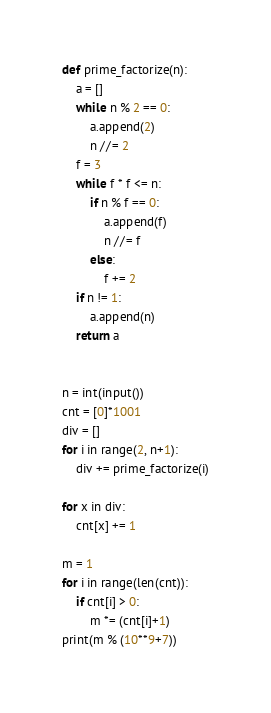<code> <loc_0><loc_0><loc_500><loc_500><_Python_>def prime_factorize(n):
    a = []
    while n % 2 == 0:
        a.append(2)
        n //= 2
    f = 3
    while f * f <= n:
        if n % f == 0:
            a.append(f)
            n //= f
        else:
            f += 2
    if n != 1:
        a.append(n)
    return a


n = int(input())
cnt = [0]*1001
div = []
for i in range(2, n+1):
    div += prime_factorize(i)

for x in div:
    cnt[x] += 1

m = 1
for i in range(len(cnt)):
    if cnt[i] > 0:
        m *= (cnt[i]+1)
print(m % (10**9+7))</code> 